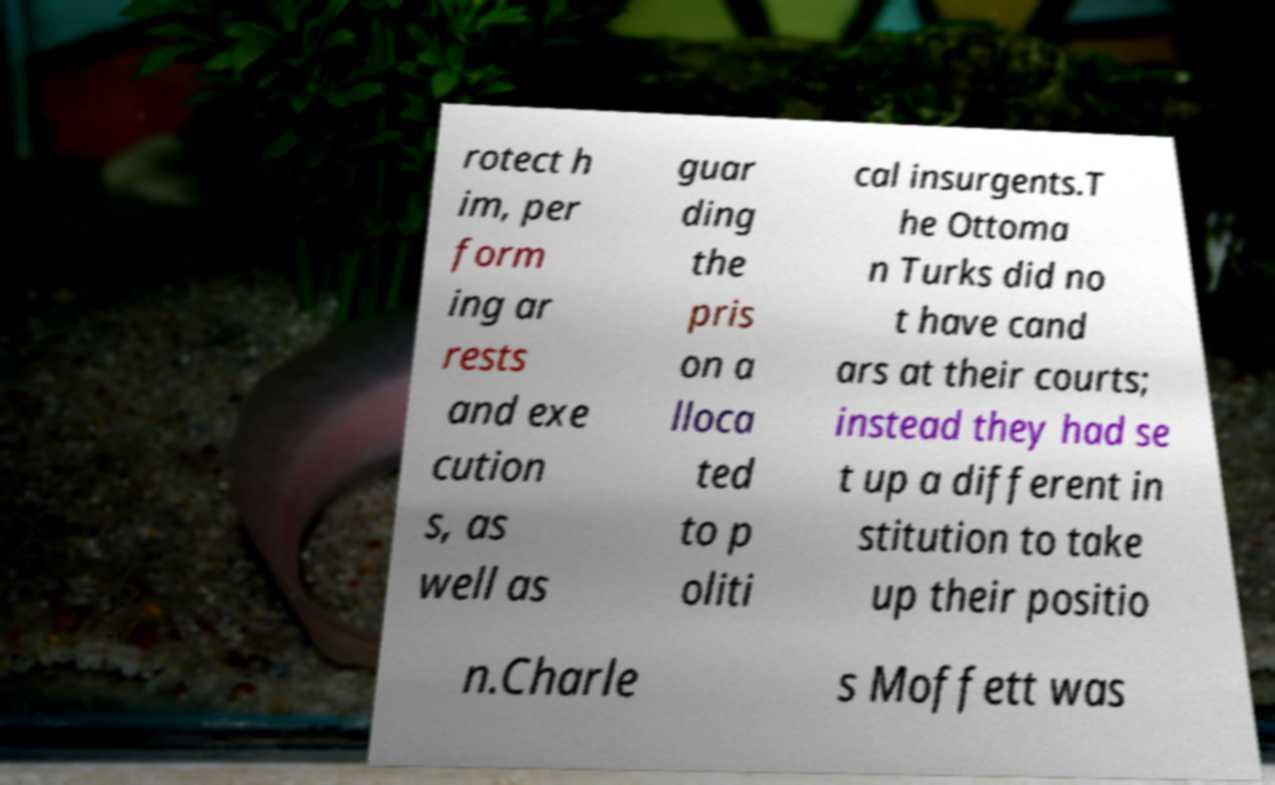Can you read and provide the text displayed in the image?This photo seems to have some interesting text. Can you extract and type it out for me? rotect h im, per form ing ar rests and exe cution s, as well as guar ding the pris on a lloca ted to p oliti cal insurgents.T he Ottoma n Turks did no t have cand ars at their courts; instead they had se t up a different in stitution to take up their positio n.Charle s Moffett was 